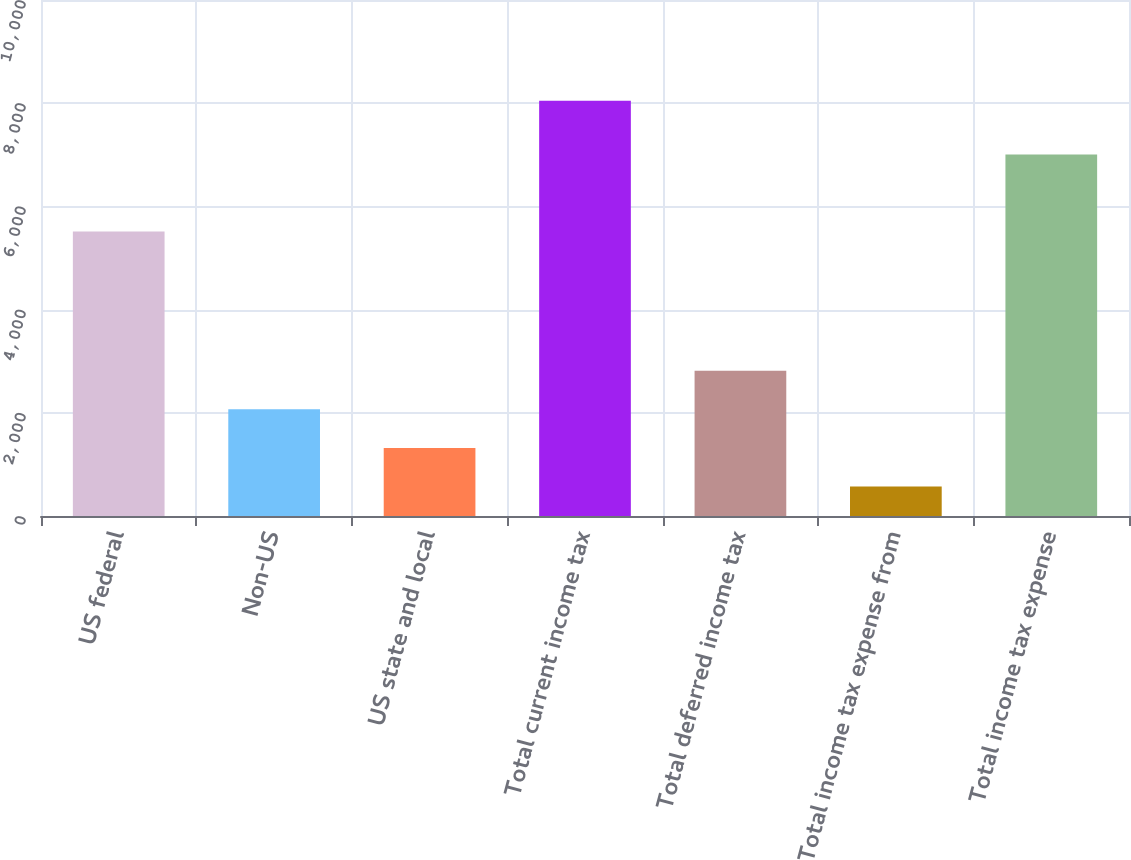<chart> <loc_0><loc_0><loc_500><loc_500><bar_chart><fcel>US federal<fcel>Non-US<fcel>US state and local<fcel>Total current income tax<fcel>Total deferred income tax<fcel>Total income tax expense from<fcel>Total income tax expense<nl><fcel>5512<fcel>2067<fcel>1319.5<fcel>8047<fcel>2814.5<fcel>572<fcel>7007<nl></chart> 